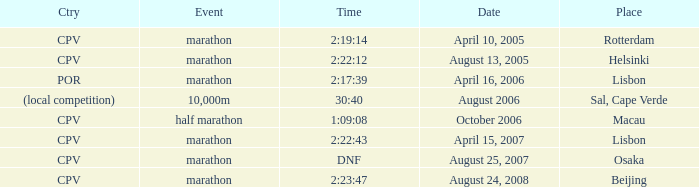What is the Event labeled Country of (local competition)? 10,000m. 